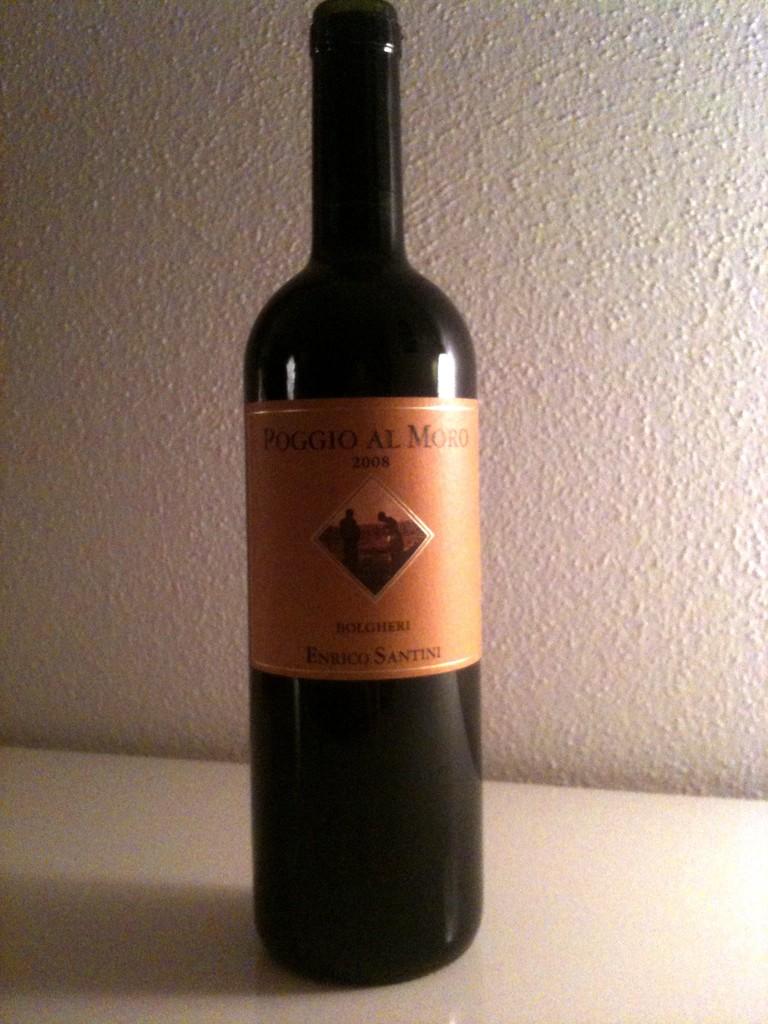What year is this wine from?
Provide a short and direct response. 2008. What is the name of this wine?
Your answer should be compact. Poggio al moro. 